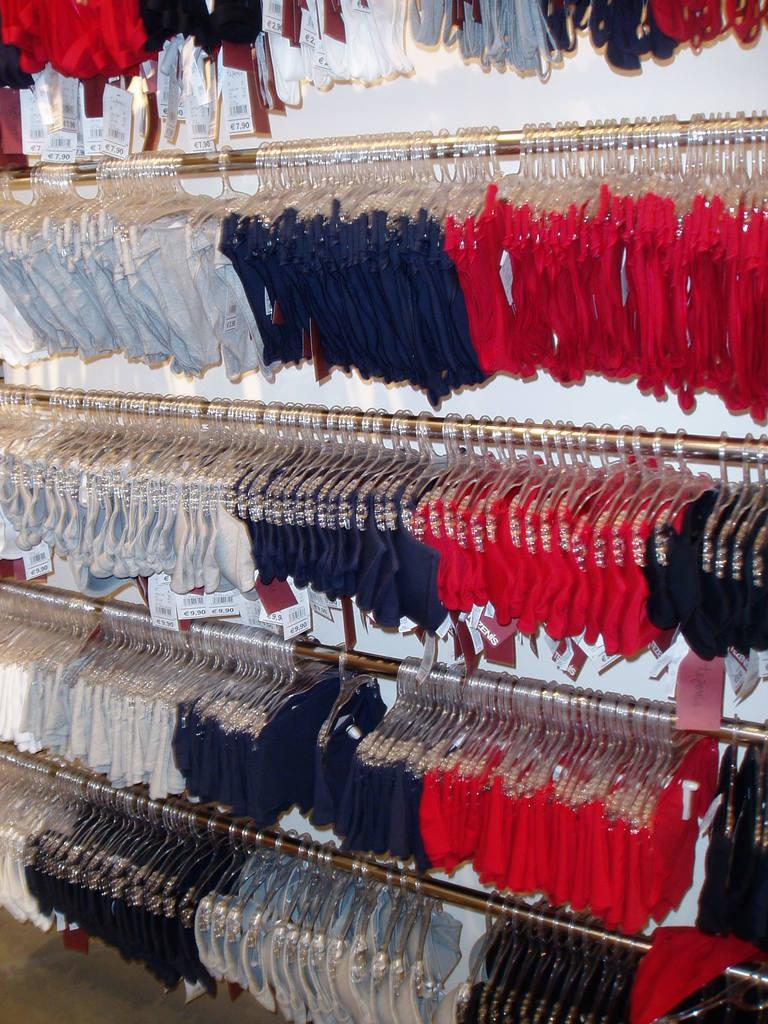What is the primary object in the image? There are clothes hung on poles in the image. How are the clothes hung on the poles? The clothes are hung using hangers. Are there any additional details about the clothes? Yes, there are rate tags on the clothes. What can be seen in the background of the image? There is a wall visible in the image. Can you tell me how many tigers are present in the image? There are no tigers present in the image; it features clothes hung on poles. What type of event is taking place in the image? There is no event depicted in the image; it shows clothes hung on poles with hangers and rate tags. 